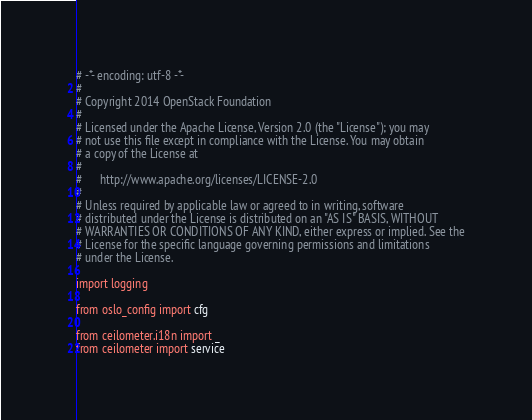Convert code to text. <code><loc_0><loc_0><loc_500><loc_500><_Python_># -*- encoding: utf-8 -*-
#
# Copyright 2014 OpenStack Foundation
#
# Licensed under the Apache License, Version 2.0 (the "License"); you may
# not use this file except in compliance with the License. You may obtain
# a copy of the License at
#
#      http://www.apache.org/licenses/LICENSE-2.0
#
# Unless required by applicable law or agreed to in writing, software
# distributed under the License is distributed on an "AS IS" BASIS, WITHOUT
# WARRANTIES OR CONDITIONS OF ANY KIND, either express or implied. See the
# License for the specific language governing permissions and limitations
# under the License.

import logging

from oslo_config import cfg

from ceilometer.i18n import _
from ceilometer import service</code> 